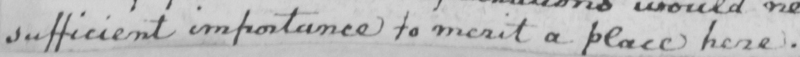Transcribe the text shown in this historical manuscript line. sufficient importance to merit a place here . 